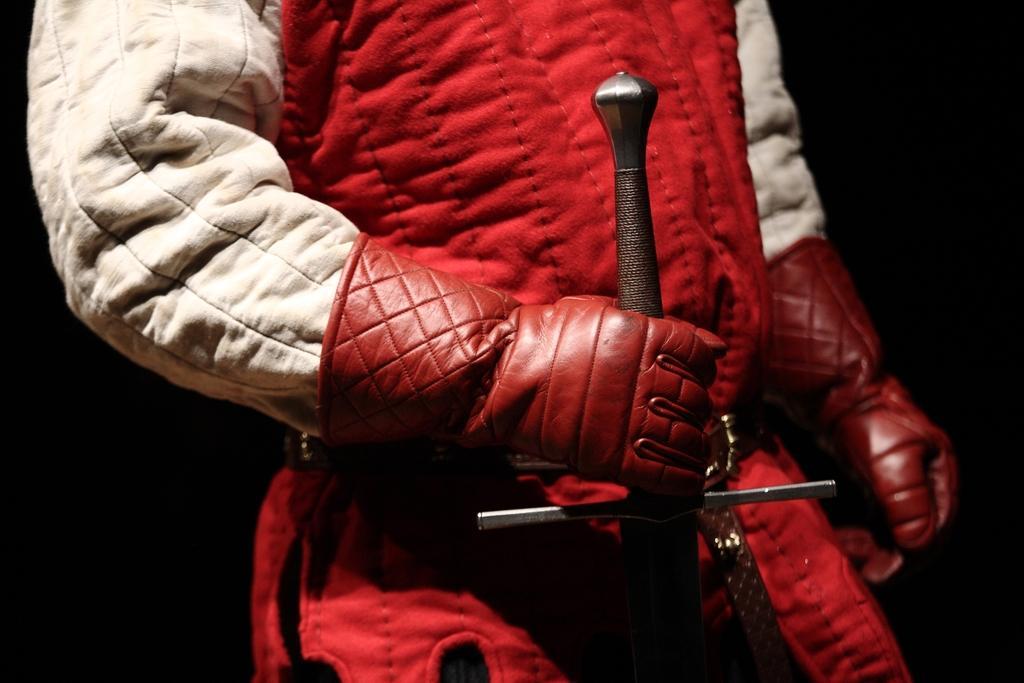Describe this image in one or two sentences. In this image, we can see a person wearing gloves and holding an object and the background is dark. 